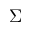Convert formula to latex. <formula><loc_0><loc_0><loc_500><loc_500>\Sigma</formula> 